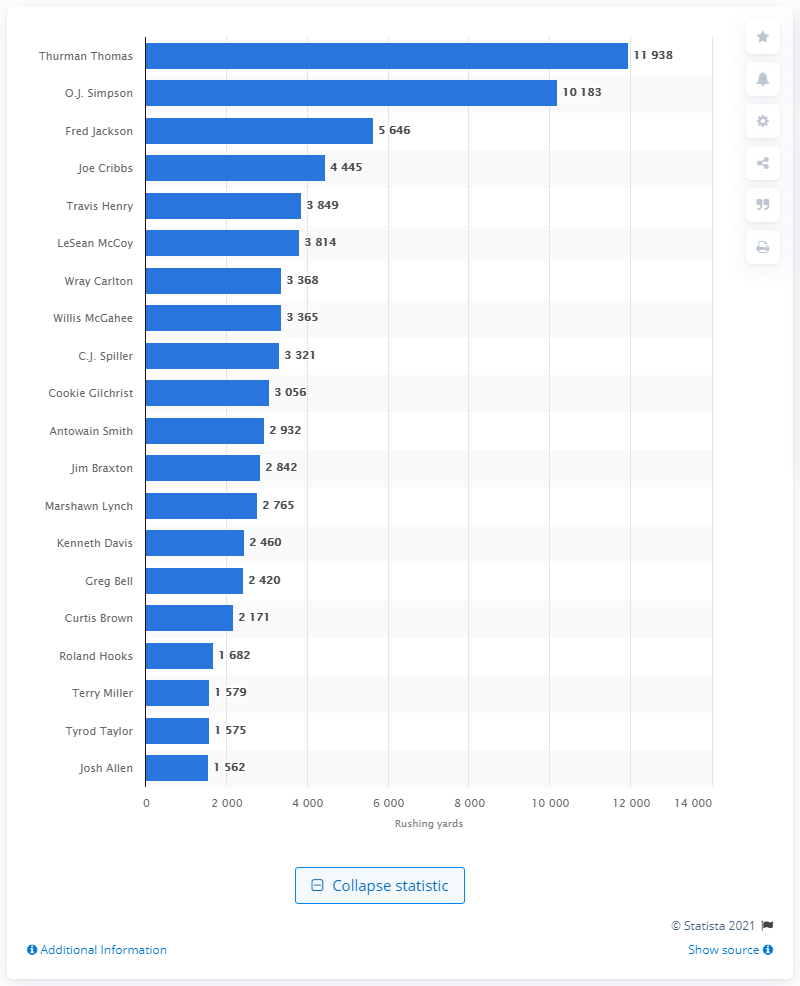Identify some key points in this picture. Thurman Thomas is the career rushing leader of the Buffalo Bills. 